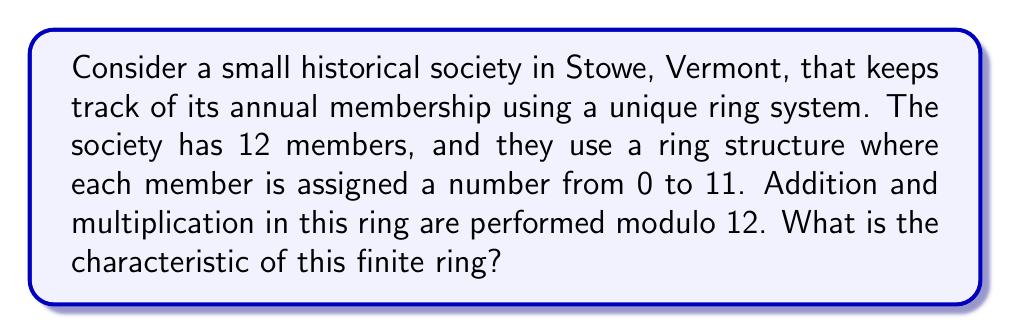Can you solve this math problem? To find the characteristic of a finite ring, we need to determine the smallest positive integer $n$ such that $n \cdot 1 = 0$ in the ring, where $1$ is the multiplicative identity of the ring.

Let's approach this step-by-step:

1) In this ring, addition and multiplication are performed modulo 12. This means that the ring is isomorphic to $\mathbb{Z}_{12}$, the ring of integers modulo 12.

2) The multiplicative identity in this ring is 1.

3) We need to find the smallest positive integer $n$ such that:

   $n \cdot 1 \equiv 0 \pmod{12}$

4) Let's calculate multiples of 1 modulo 12:
   
   $1 \cdot 1 \equiv 1 \pmod{12}$
   $2 \cdot 1 \equiv 2 \pmod{12}$
   $3 \cdot 1 \equiv 3 \pmod{12}$
   ...
   $11 \cdot 1 \equiv 11 \pmod{12}$
   $12 \cdot 1 \equiv 0 \pmod{12}$

5) We see that $12$ is the smallest positive integer that satisfies the condition.

Therefore, the characteristic of this ring is 12.

Note: In general, for the ring $\mathbb{Z}_n$, the characteristic is always $n$.
Answer: The characteristic of the finite ring is 12. 